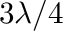<formula> <loc_0><loc_0><loc_500><loc_500>3 \lambda / 4</formula> 